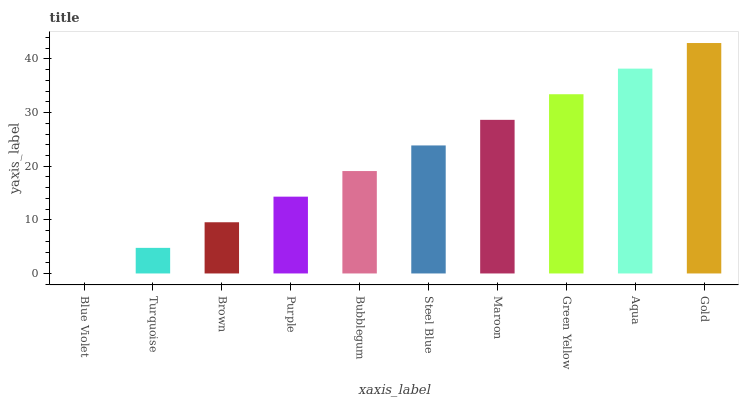Is Blue Violet the minimum?
Answer yes or no. Yes. Is Gold the maximum?
Answer yes or no. Yes. Is Turquoise the minimum?
Answer yes or no. No. Is Turquoise the maximum?
Answer yes or no. No. Is Turquoise greater than Blue Violet?
Answer yes or no. Yes. Is Blue Violet less than Turquoise?
Answer yes or no. Yes. Is Blue Violet greater than Turquoise?
Answer yes or no. No. Is Turquoise less than Blue Violet?
Answer yes or no. No. Is Steel Blue the high median?
Answer yes or no. Yes. Is Bubblegum the low median?
Answer yes or no. Yes. Is Green Yellow the high median?
Answer yes or no. No. Is Brown the low median?
Answer yes or no. No. 